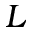Convert formula to latex. <formula><loc_0><loc_0><loc_500><loc_500>L</formula> 